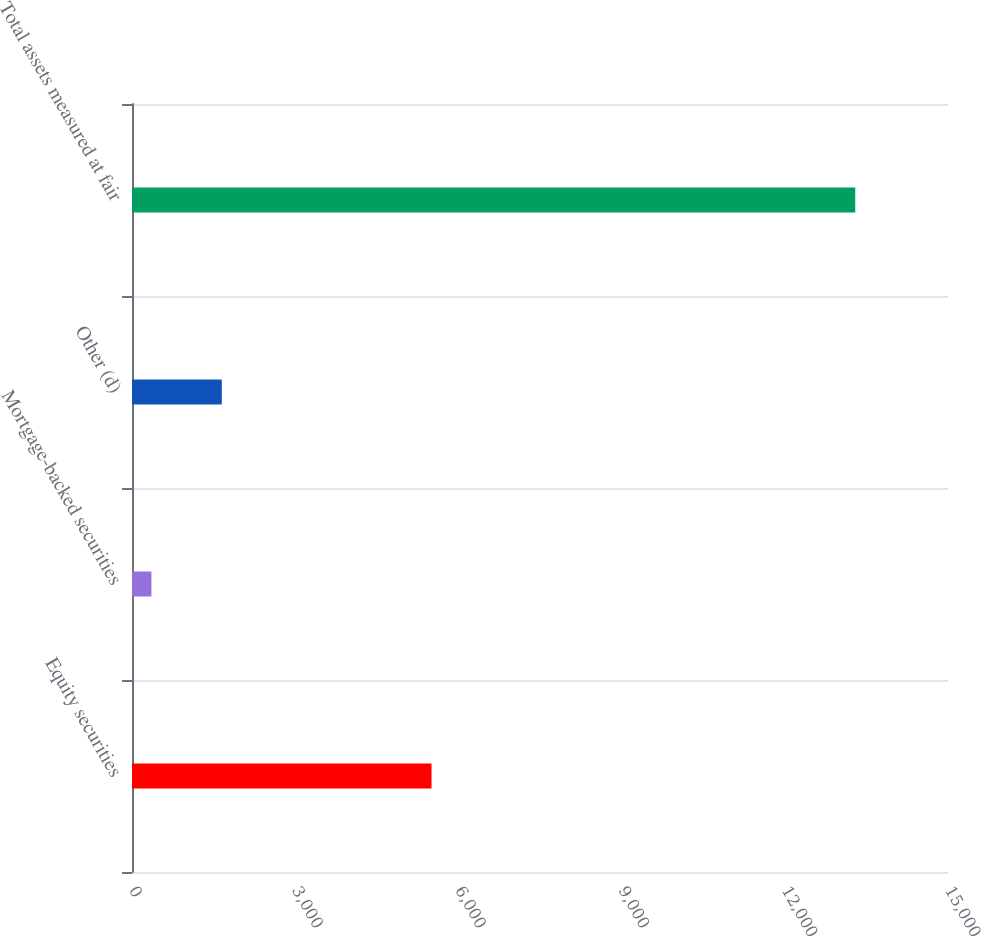<chart> <loc_0><loc_0><loc_500><loc_500><bar_chart><fcel>Equity securities<fcel>Mortgage-backed securities<fcel>Other (d)<fcel>Total assets measured at fair<nl><fcel>5506<fcel>357<fcel>1650.8<fcel>13295<nl></chart> 